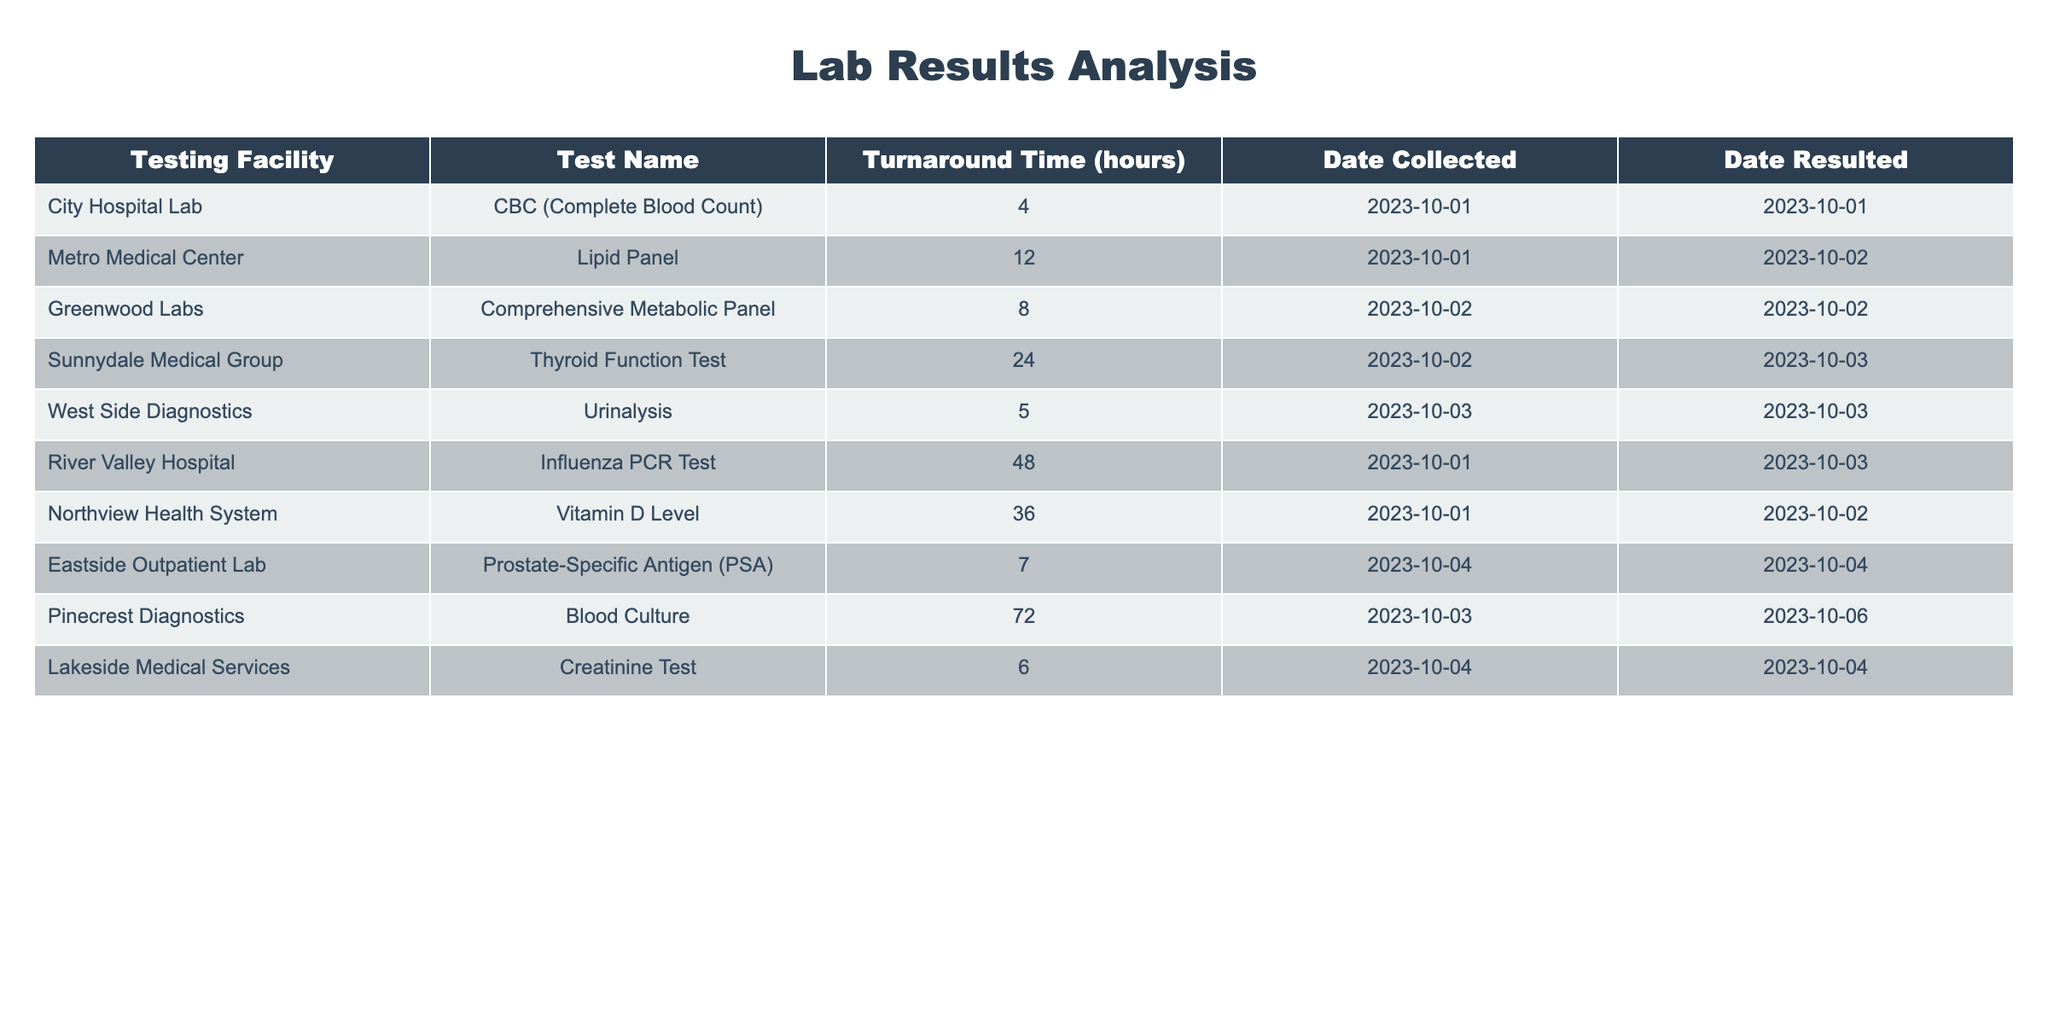What is the turnaround time for the CBC test conducted at City Hospital Lab? The table indicates that the turnaround time for the CBC test at City Hospital Lab is listed in the "Turnaround Time (hours)" column next to the corresponding test name and facility. The value is 4 hours.
Answer: 4 hours Which testing facility took the longest to result the lab tests? To determine the facility with the longest turnaround time, we can look at the "Turnaround Time (hours)" column and identify the maximum value. The highest value is 72 hours, which corresponds to Pinecrest Diagnostics.
Answer: Pinecrest Diagnostics What is the average turnaround time for all tests listed in the table? To calculate the average turnaround time, sum the "Turnaround Time (hours)" values: (4 + 12 + 8 + 24 + 5 + 48 + 36 + 7 + 72 + 6) = 222 hours. Since there are 10 tests, dividing 222 by 10 gives an average of 22.2 hours.
Answer: 22.2 hours Did River Valley Hospital have a turnaround time shorter than 50 hours? By examining the table, the turnaround time for River Valley Hospital is 48 hours, which is indeed shorter than 50 hours. Therefore, the answer is yes.
Answer: Yes How many tests had a turnaround time greater than or equal to 30 hours? We need to count the number of tests where the turnaround time is 30 hours or more. The facilities are Northview Health System (36 hours) and Pinecrest Diagnostics (72 hours), making a total of 2 tests that meet this criterion.
Answer: 2 tests What is the difference in turnaround time between the longest and shortest test results? The longest turnaround time is 72 hours (Pinecrest Diagnostics) and the shortest is 4 hours (City Hospital Lab). The difference is calculated as 72 - 4 = 68 hours.
Answer: 68 hours Which test had the second shortest turnaround time, and what was its time? To find the second shortest turnaround time, we list the turnaround times in ascending order: 4, 5, 6, 7, 8, 12, 24, 36, 48, 72 hours. The second shortest is 5 hours for the Urinalysis by West Side Diagnostics.
Answer: Urinalysis, 5 hours Is there a test with a turnaround time of 20 hours or more conducted on October 2, 2023? Looking at the data for tests conducted on October 2, 2023, we have the Thyroid Function Test (24 hours) from Sunnydale Medical Group, which meets the criteria. Thus, the answer is yes.
Answer: Yes 